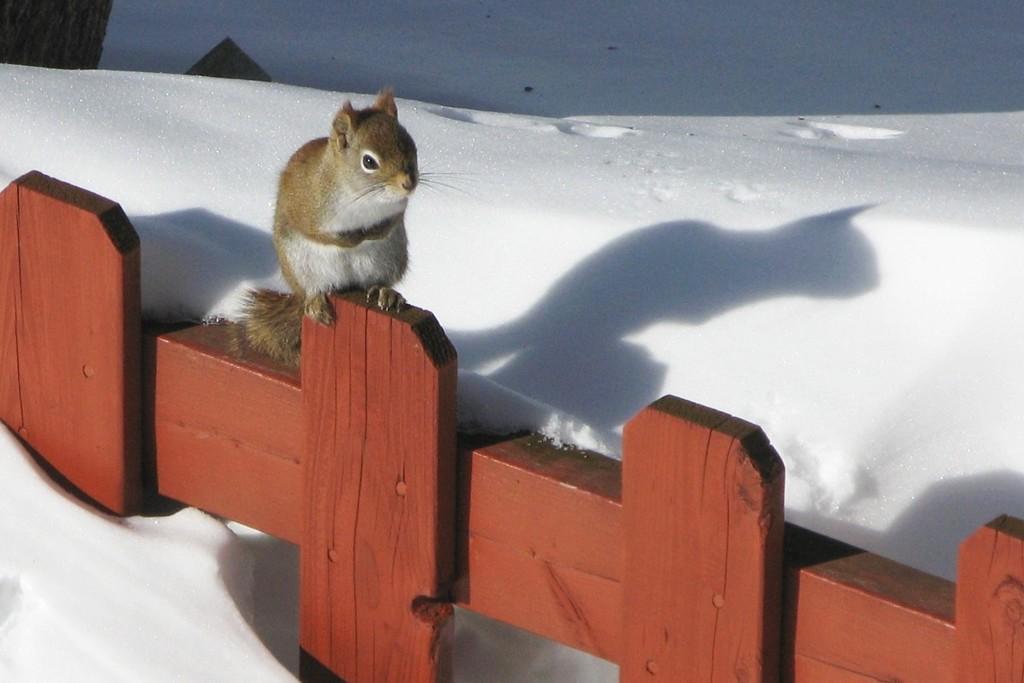Can you describe this image briefly? In this image there is a squirrel siting on the wooden fence. At the bottom there is snow. On the left side top there is a tree. 